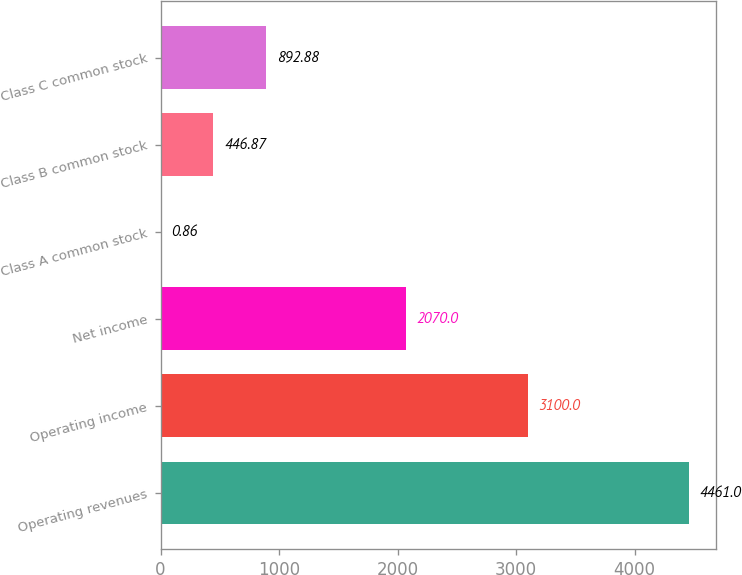Convert chart to OTSL. <chart><loc_0><loc_0><loc_500><loc_500><bar_chart><fcel>Operating revenues<fcel>Operating income<fcel>Net income<fcel>Class A common stock<fcel>Class B common stock<fcel>Class C common stock<nl><fcel>4461<fcel>3100<fcel>2070<fcel>0.86<fcel>446.87<fcel>892.88<nl></chart> 